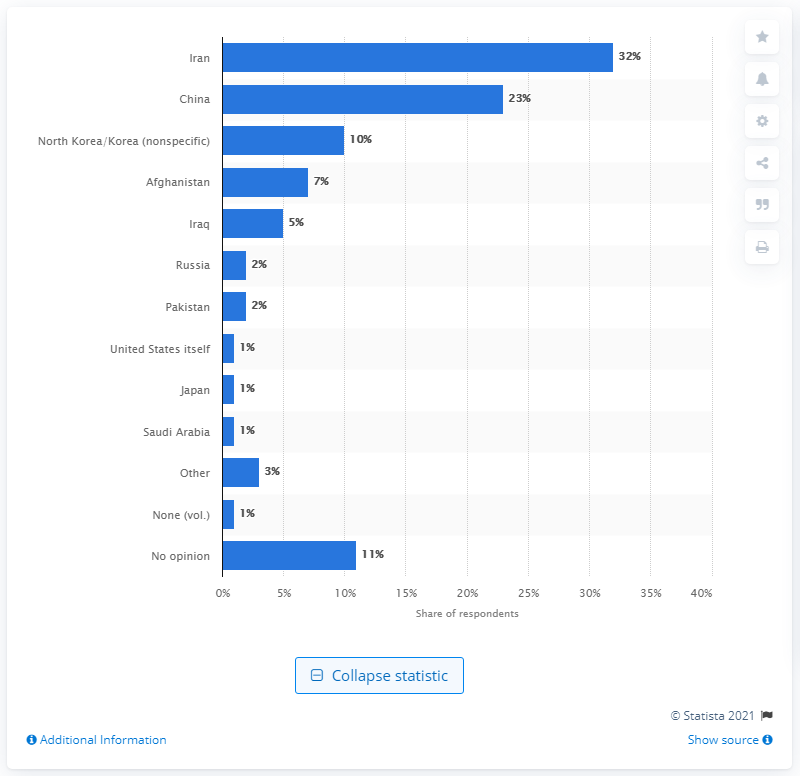Indicate a few pertinent items in this graphic. In February 2012, a survey conducted by a reputable source found that 32% of respondents considered Iran to be the greatest enemy of the United States. 